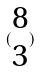<formula> <loc_0><loc_0><loc_500><loc_500>( \begin{matrix} 8 \\ 3 \end{matrix} )</formula> 